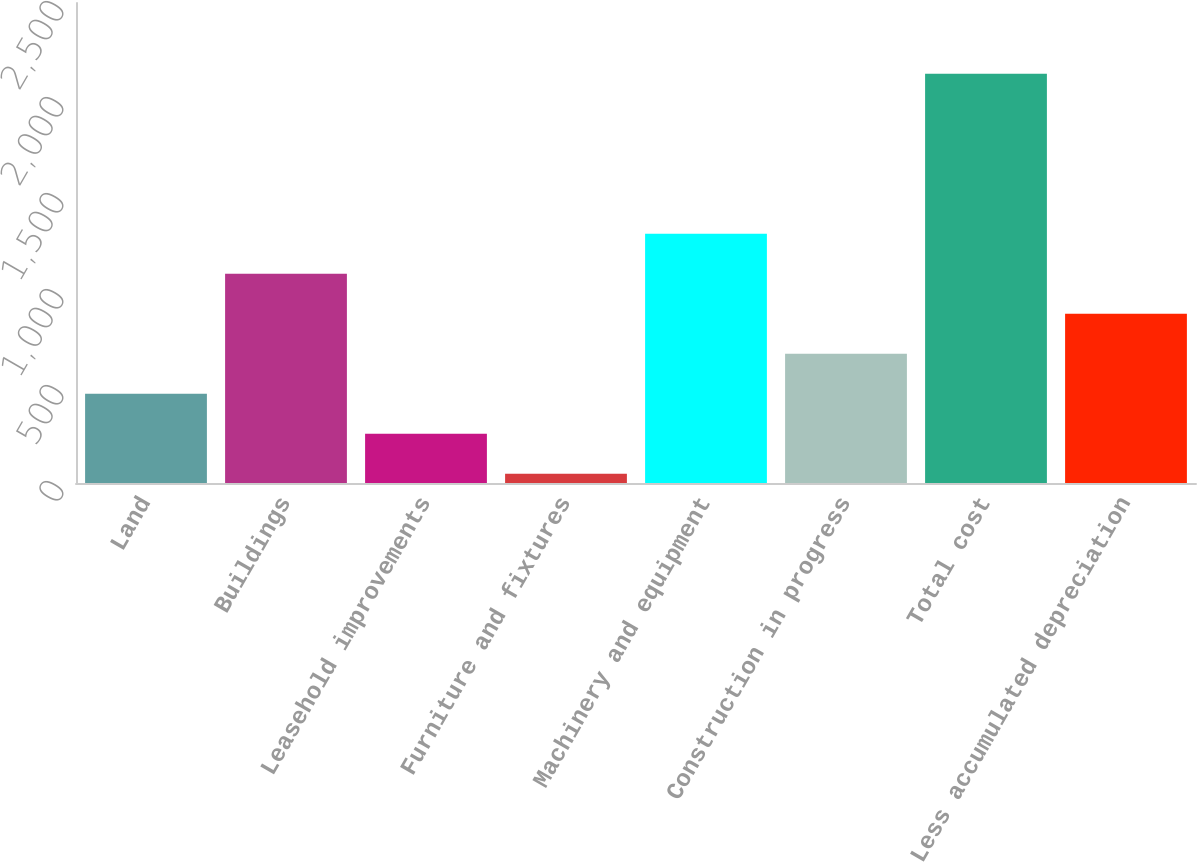Convert chart. <chart><loc_0><loc_0><loc_500><loc_500><bar_chart><fcel>Land<fcel>Buildings<fcel>Leasehold improvements<fcel>Furniture and fixtures<fcel>Machinery and equipment<fcel>Construction in progress<fcel>Total cost<fcel>Less accumulated depreciation<nl><fcel>464.84<fcel>1089.95<fcel>256.47<fcel>48.1<fcel>1298.32<fcel>673.21<fcel>2131.8<fcel>881.58<nl></chart> 